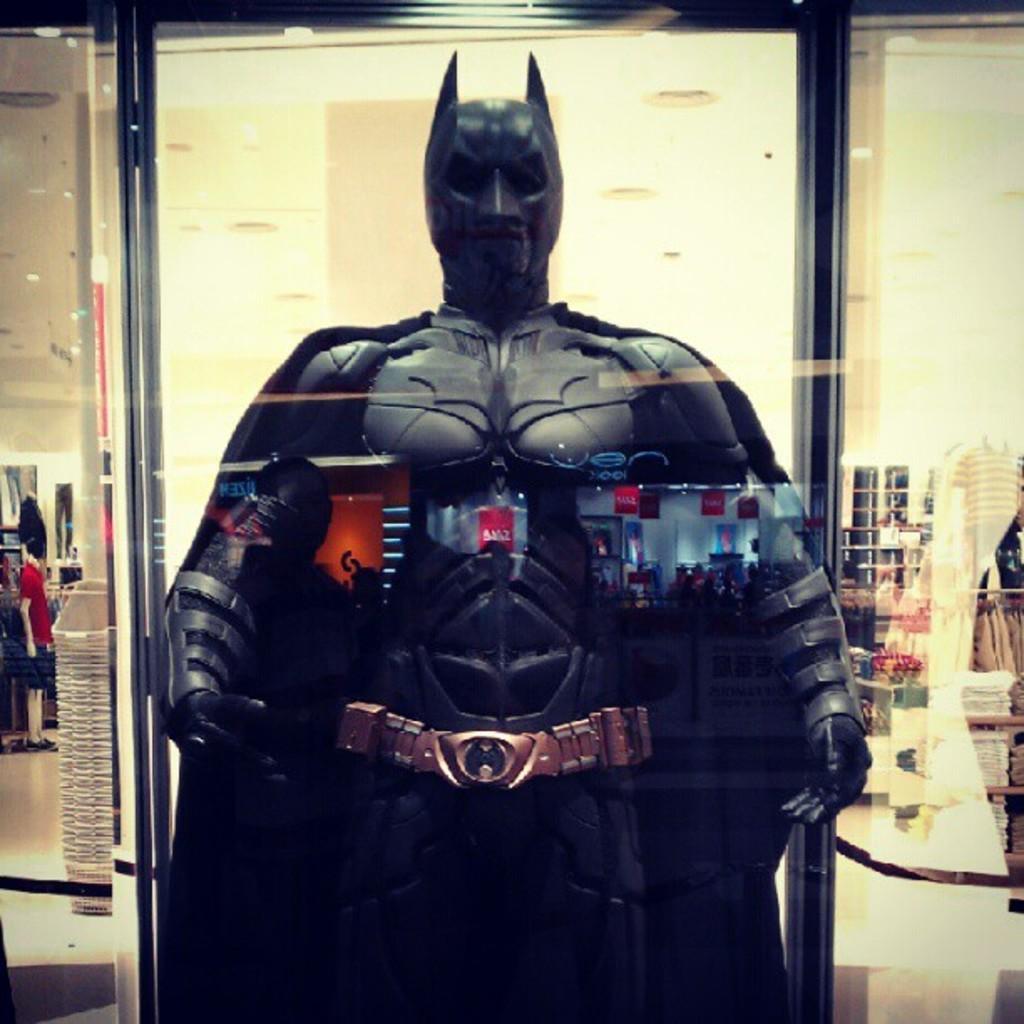Describe this image in one or two sentences. In this picture I can observe a costume of a batman which is in black color. In the background there is a wall. 